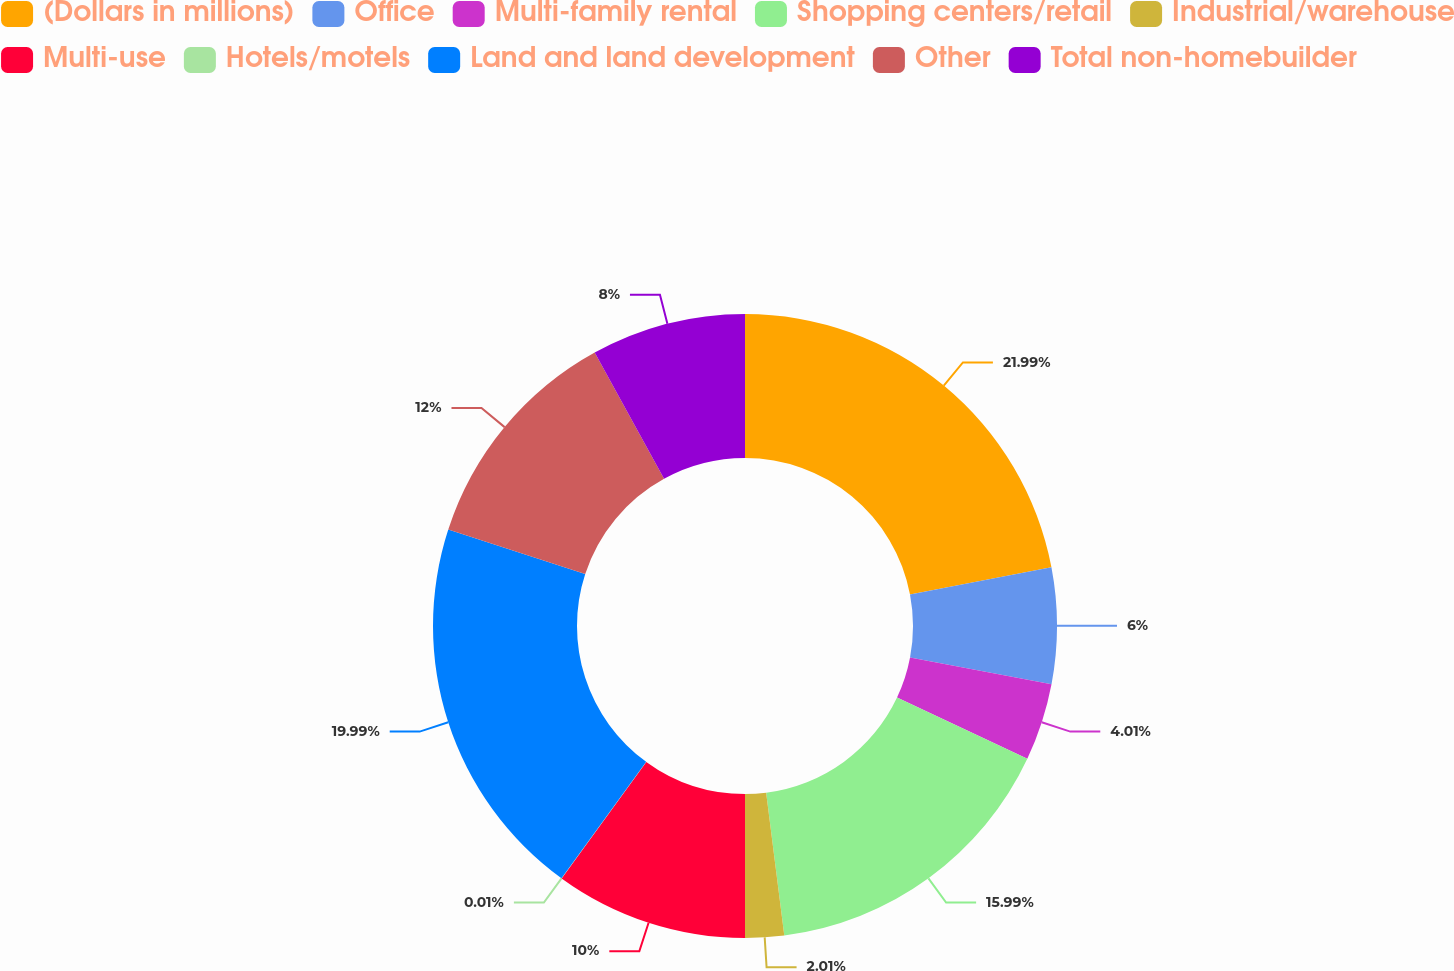Convert chart to OTSL. <chart><loc_0><loc_0><loc_500><loc_500><pie_chart><fcel>(Dollars in millions)<fcel>Office<fcel>Multi-family rental<fcel>Shopping centers/retail<fcel>Industrial/warehouse<fcel>Multi-use<fcel>Hotels/motels<fcel>Land and land development<fcel>Other<fcel>Total non-homebuilder<nl><fcel>21.99%<fcel>6.0%<fcel>4.01%<fcel>15.99%<fcel>2.01%<fcel>10.0%<fcel>0.01%<fcel>19.99%<fcel>12.0%<fcel>8.0%<nl></chart> 